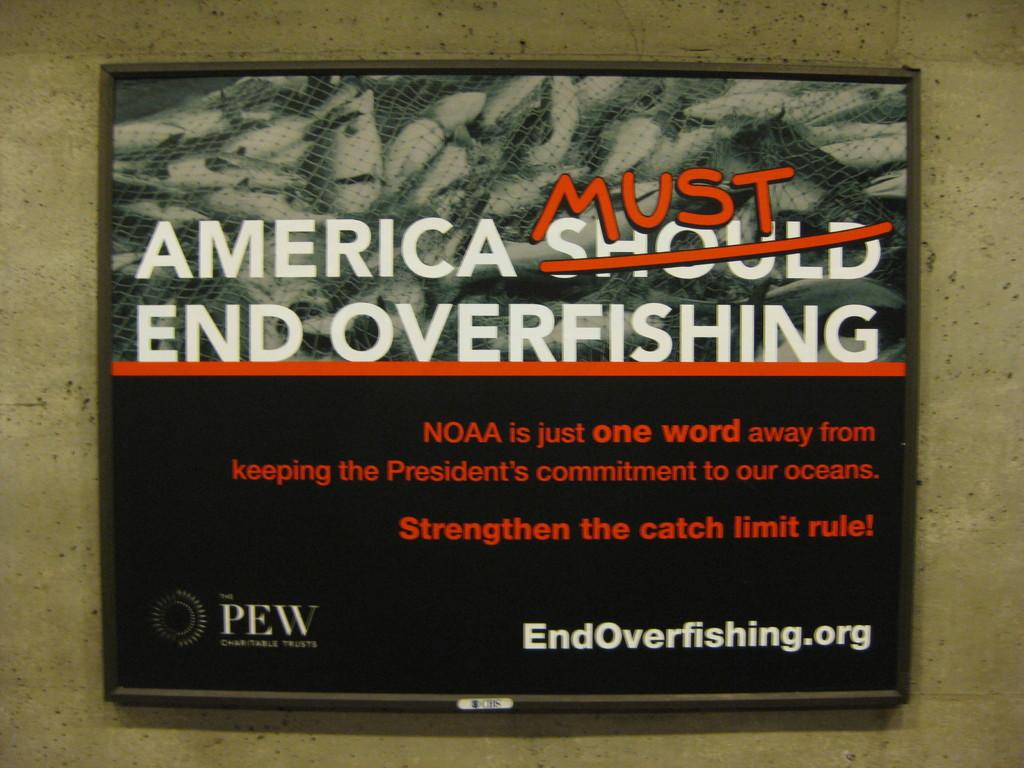What is the domain name at the bottom?
Give a very brief answer. Endoverfishing.org. What is the title name?
Offer a terse response. America must end overfishing. 